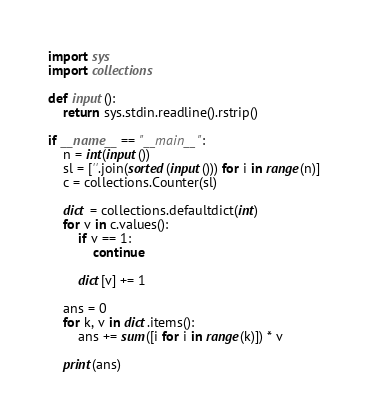Convert code to text. <code><loc_0><loc_0><loc_500><loc_500><_Python_>import sys
import collections

def input():
    return sys.stdin.readline().rstrip()

if __name__ == "__main__":
    n = int(input())
    sl = [''.join(sorted(input())) for i in range(n)]
    c = collections.Counter(sl)

    dict = collections.defaultdict(int)
    for v in c.values():
        if v == 1:
            continue

        dict[v] += 1

    ans = 0
    for k, v in dict.items():
        ans += sum([i for i in range(k)]) * v

    print(ans)
</code> 